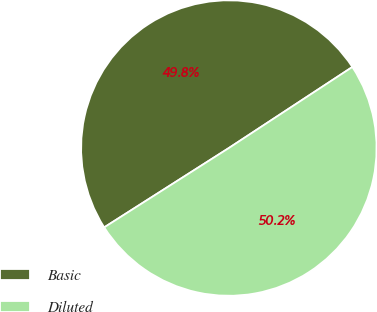<chart> <loc_0><loc_0><loc_500><loc_500><pie_chart><fcel>Basic<fcel>Diluted<nl><fcel>49.78%<fcel>50.22%<nl></chart> 